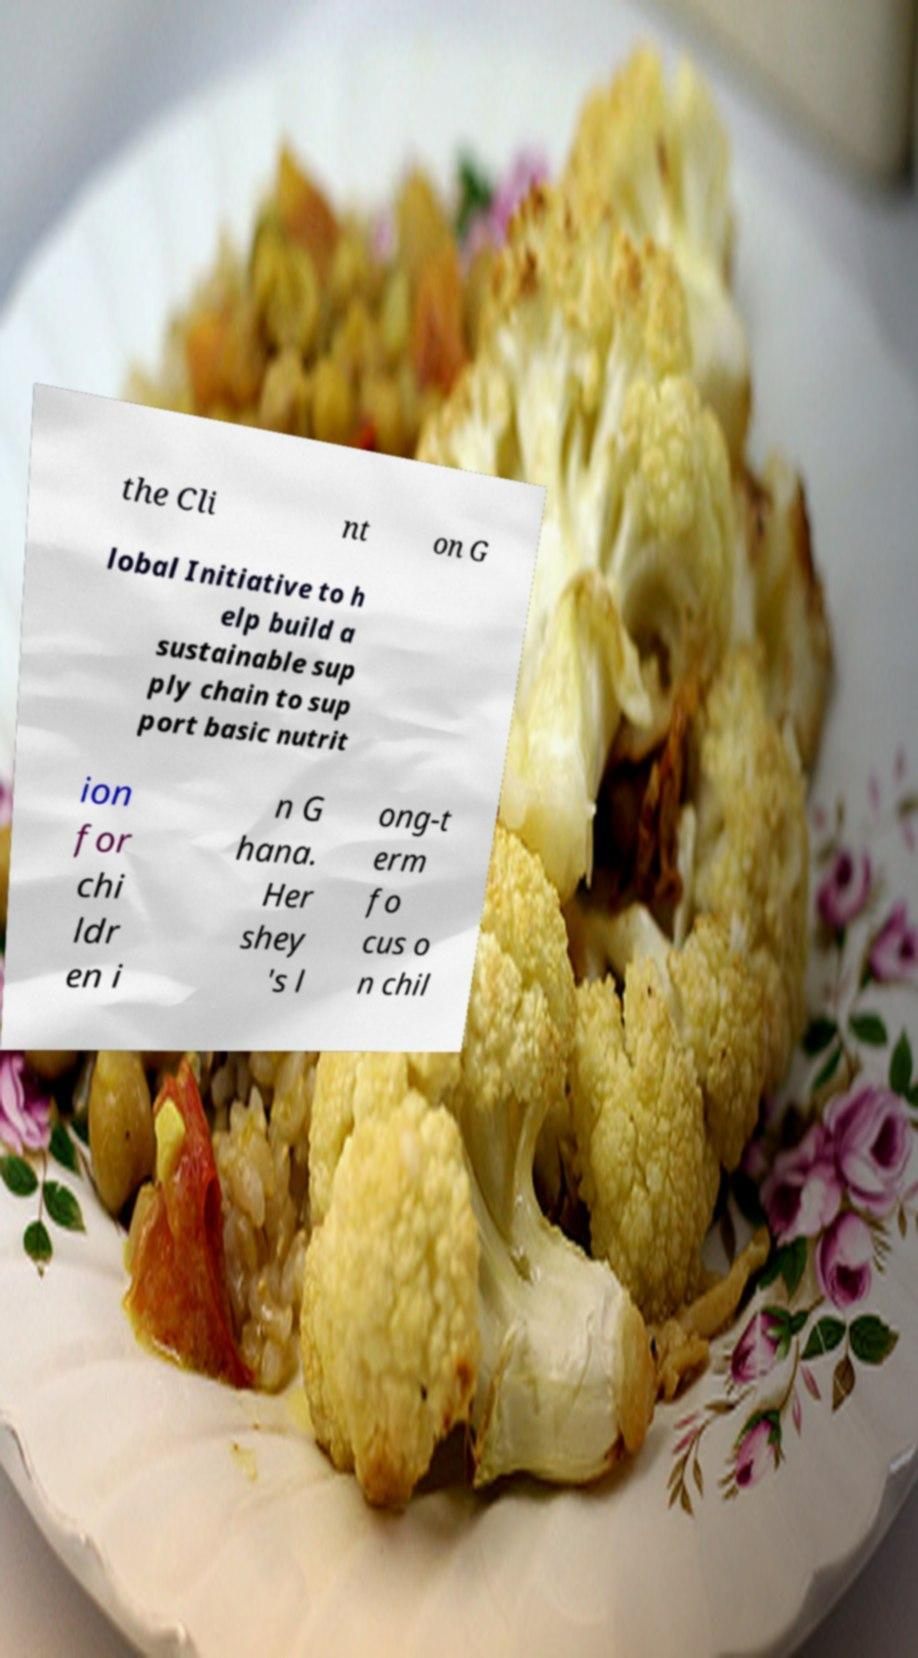Could you assist in decoding the text presented in this image and type it out clearly? the Cli nt on G lobal Initiative to h elp build a sustainable sup ply chain to sup port basic nutrit ion for chi ldr en i n G hana. Her shey 's l ong-t erm fo cus o n chil 